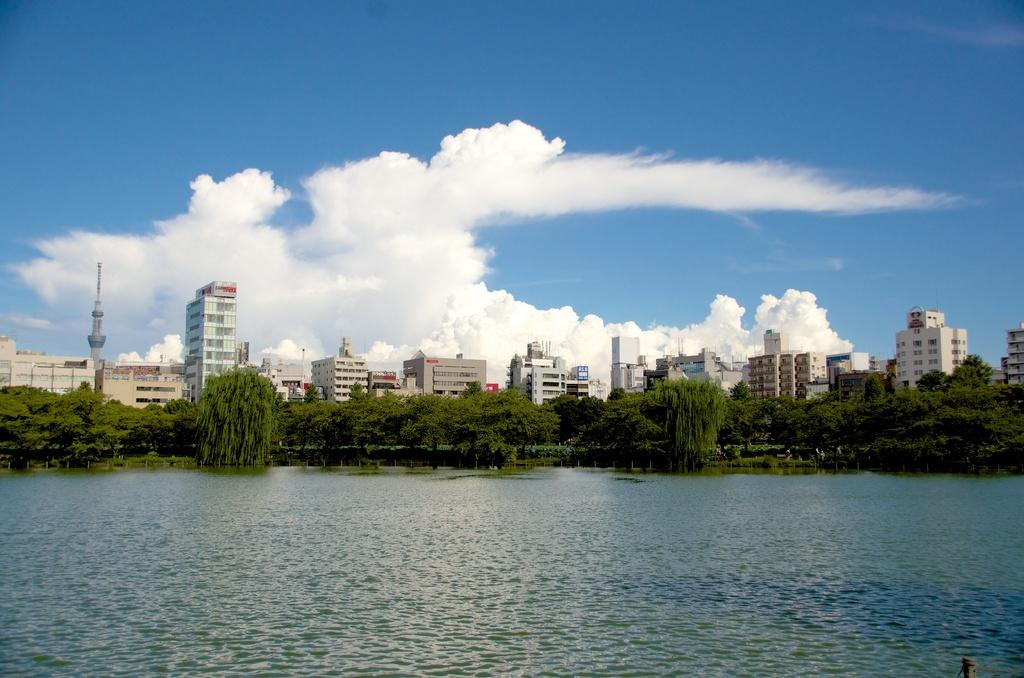What is the primary element visible in the image? There is water in the image. What can be seen in the background of the image? There are trees and buildings in the background of the image. What is visible in the sky in the image? There are clouds in the sky. How many tomatoes are hanging from the trees in the image? There are no tomatoes visible in the image; only trees are present in the background. What type of transport can be seen in the image? There is no transport visible in the image; the focus is on the water, trees, buildings, and clouds. 